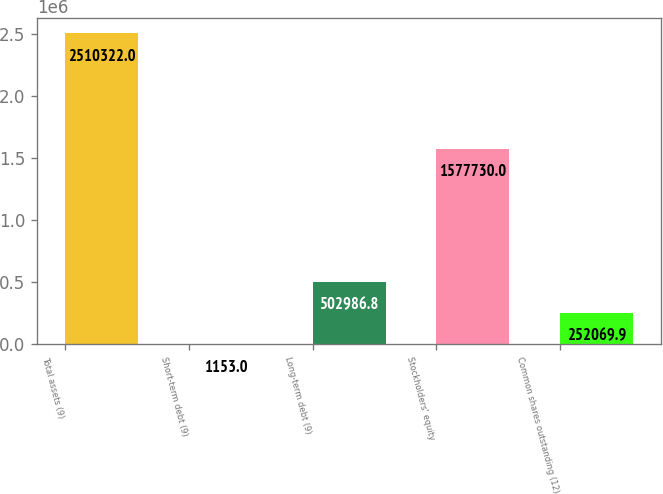<chart> <loc_0><loc_0><loc_500><loc_500><bar_chart><fcel>Total assets (9)<fcel>Short-term debt (9)<fcel>Long-term debt (9)<fcel>Stockholders' equity<fcel>Common shares outstanding (12)<nl><fcel>2.51032e+06<fcel>1153<fcel>502987<fcel>1.57773e+06<fcel>252070<nl></chart> 